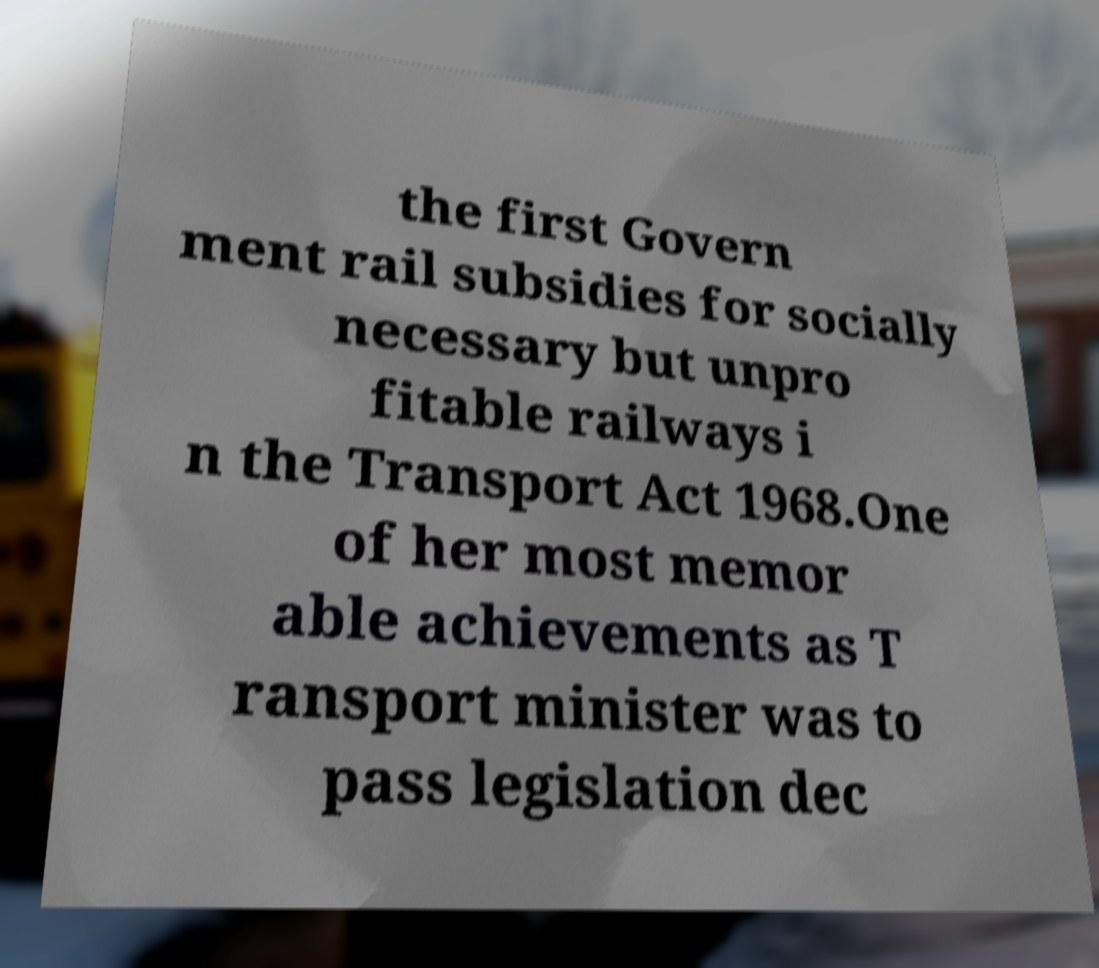There's text embedded in this image that I need extracted. Can you transcribe it verbatim? the first Govern ment rail subsidies for socially necessary but unpro fitable railways i n the Transport Act 1968.One of her most memor able achievements as T ransport minister was to pass legislation dec 